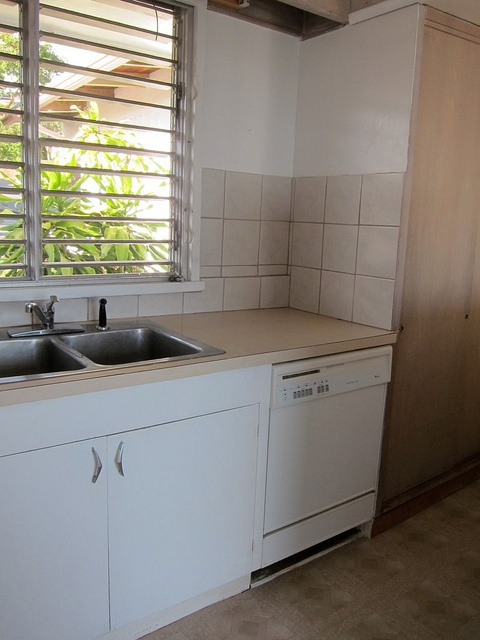Describe the objects in this image and their specific colors. I can see oven in tan, gray, and black tones, sink in tan, gray, black, and darkgray tones, and sink in tan, black, gray, and darkgray tones in this image. 